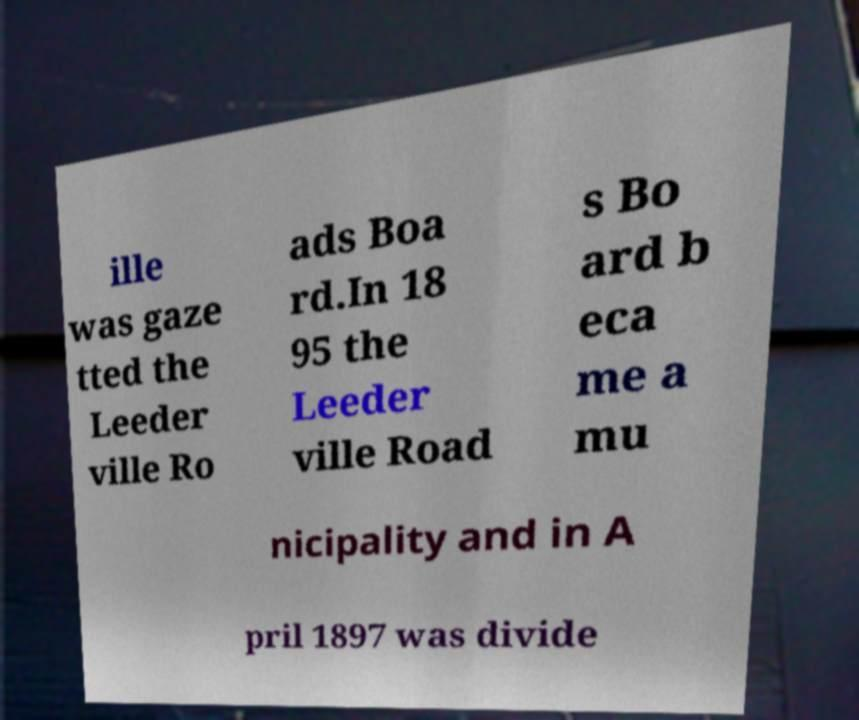Please identify and transcribe the text found in this image. ille was gaze tted the Leeder ville Ro ads Boa rd.In 18 95 the Leeder ville Road s Bo ard b eca me a mu nicipality and in A pril 1897 was divide 